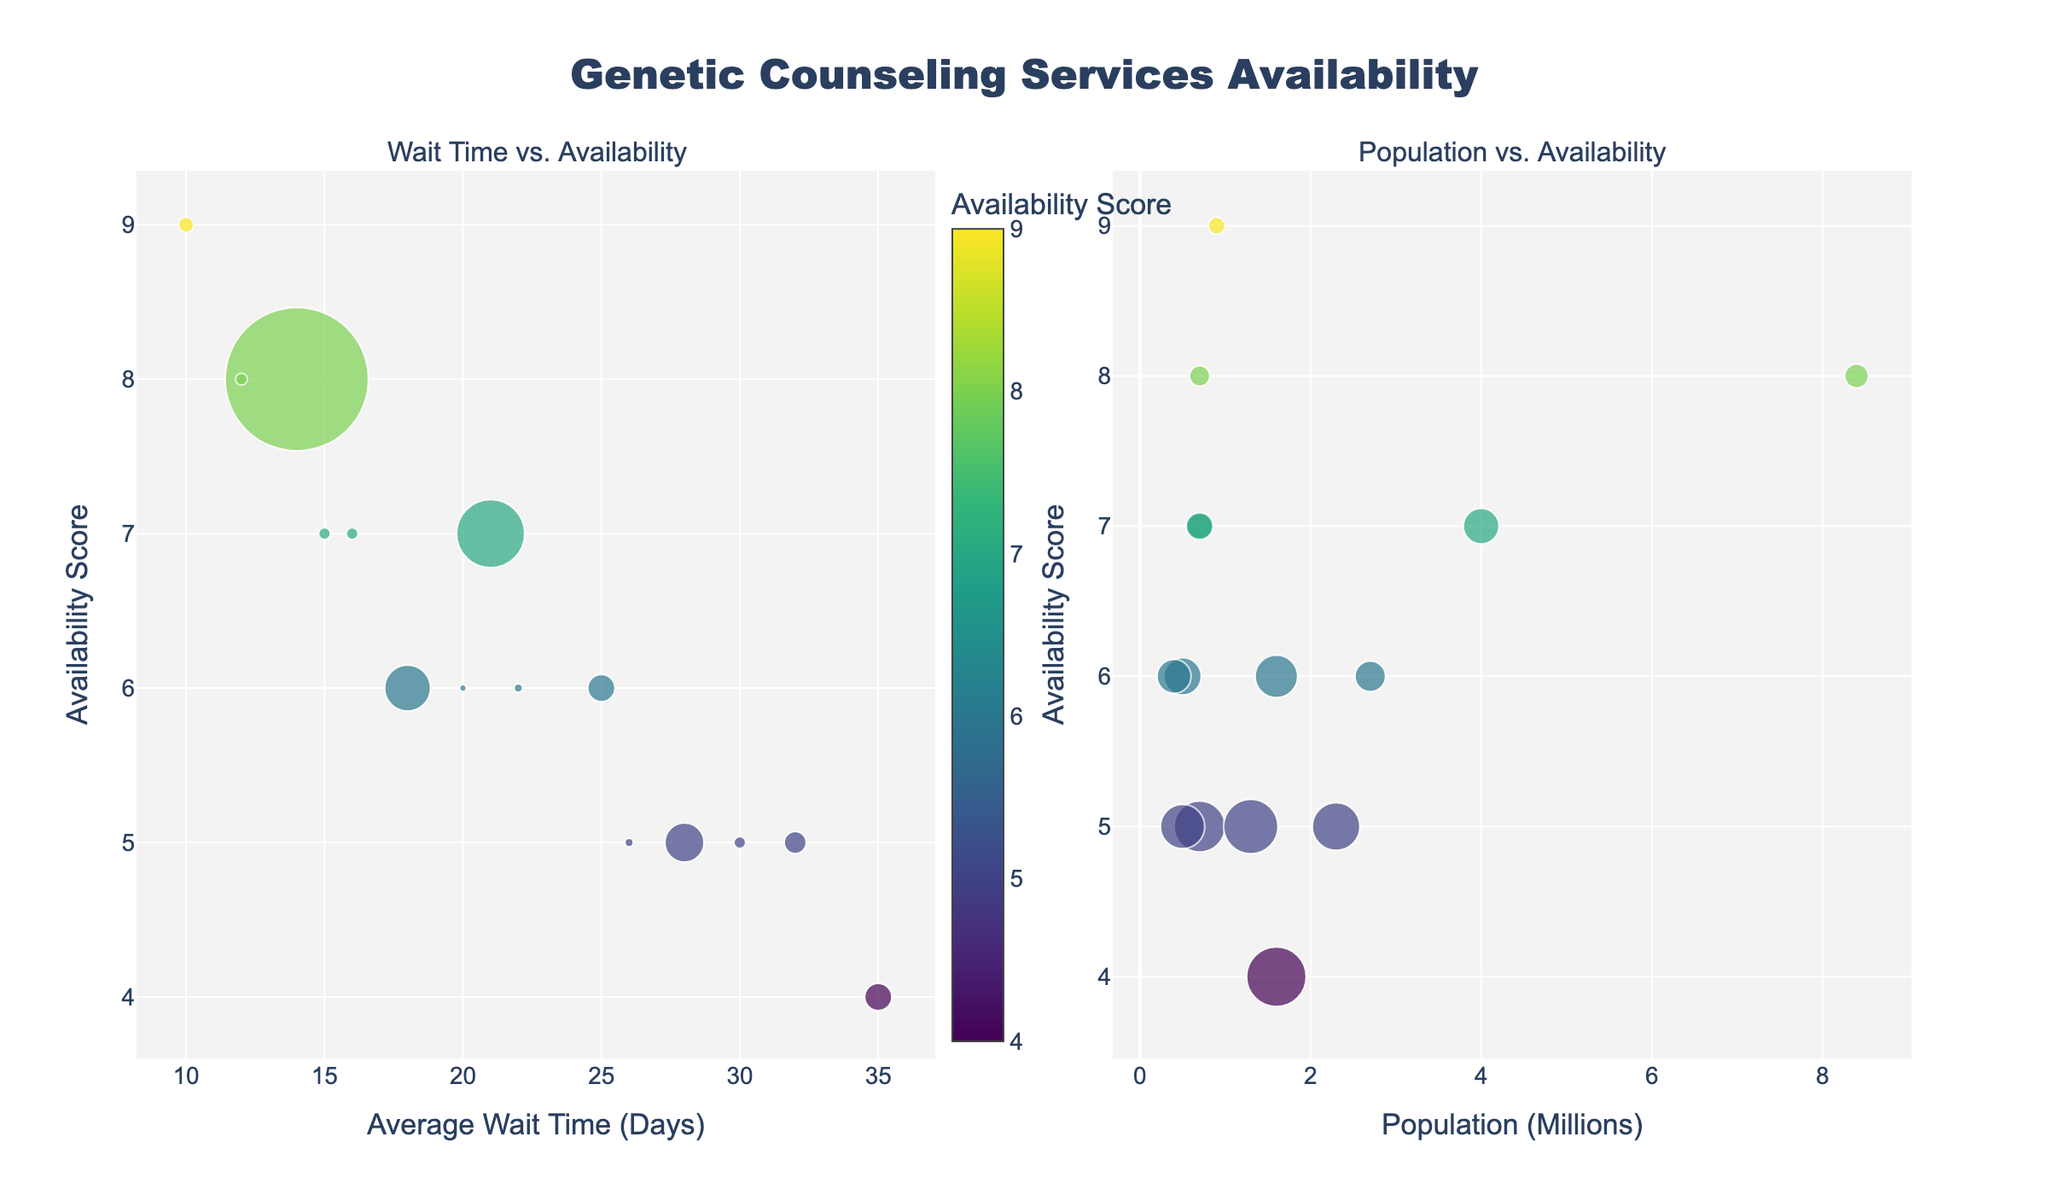What is the title of the figure? The title of the figure is located at the top of the plot. It reads "Genetic Counseling Services Availability." This title provides an overview of what the figure is about.
Answer: Genetic Counseling Services Availability What are the axes labels for the first subplot? The first subplot's x-axis is labeled "Average Wait Time (Days)," and the y-axis is labeled "Availability Score." These labels help in understanding the data dimensions being compared.
Answer: Average Wait Time (Days) and Availability Score Which region has the shortest average wait time for genetic counseling services? To find the region with the shortest wait time, look for the data point with the smallest x-value in the first subplot. The region with the shortest average wait time is "San Francisco."
Answer: San Francisco Which region has the highest availability score? The region with the highest availability score will be the data point at the top of the plots (highest y-value). "San Francisco" has the highest availability score of 9.
Answer: San Francisco What is the bubble size indicative of in the first subplot? The bubble size in the first subplot represents the population of the region. Larger bubbles indicate a larger population size.
Answer: Population Which region has the longest average wait time compared to its availability score? Look for the data point furthest to the right on the x-axis in the first subplot. "Phoenix" has the longest average wait time of 35 days and a lower availability score of 4.
Answer: Phoenix How does the availability score correlate with population size in the second subplot? By examining the second subplot, one can observe that regions with higher populations generally do not have a higher availability score. For instance, larger bubbles (representing bigger populations) are spread across different availability scores.
Answer: No clear correlation Which regions have a population between 1 and 2 million and what are their availability scores? Look for bubbles within the range of 1 to 2 million on the x-axis of the second subplot. The regions are "Phoenix" and "Dallas," both having an availability score of 5.
Answer: Phoenix and Dallas, score of 5 What is the general trend observed between average wait time and availability score in the first subplot? To determine the trend, observe the spread of data points in the first subplot. In general, a higher availability score corresponds with a shorter wait time, indicating an inverse relationship between the two variables.
Answer: Higher availability, shorter wait time Which region seems to have a favorable balance of shorter wait time and higher availability score? By looking for a region with a relatively low average wait time and high availability score in the first subplot, "San Francisco" with 10 days wait time and availability score of 9 seems the most favorable.
Answer: San Francisco 